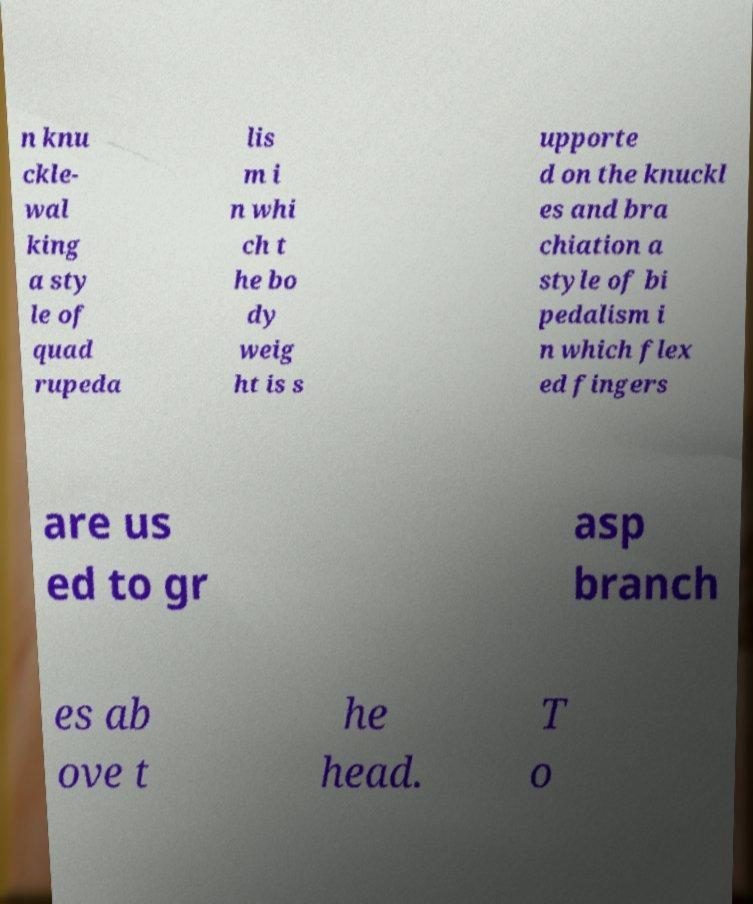What messages or text are displayed in this image? I need them in a readable, typed format. n knu ckle- wal king a sty le of quad rupeda lis m i n whi ch t he bo dy weig ht is s upporte d on the knuckl es and bra chiation a style of bi pedalism i n which flex ed fingers are us ed to gr asp branch es ab ove t he head. T o 